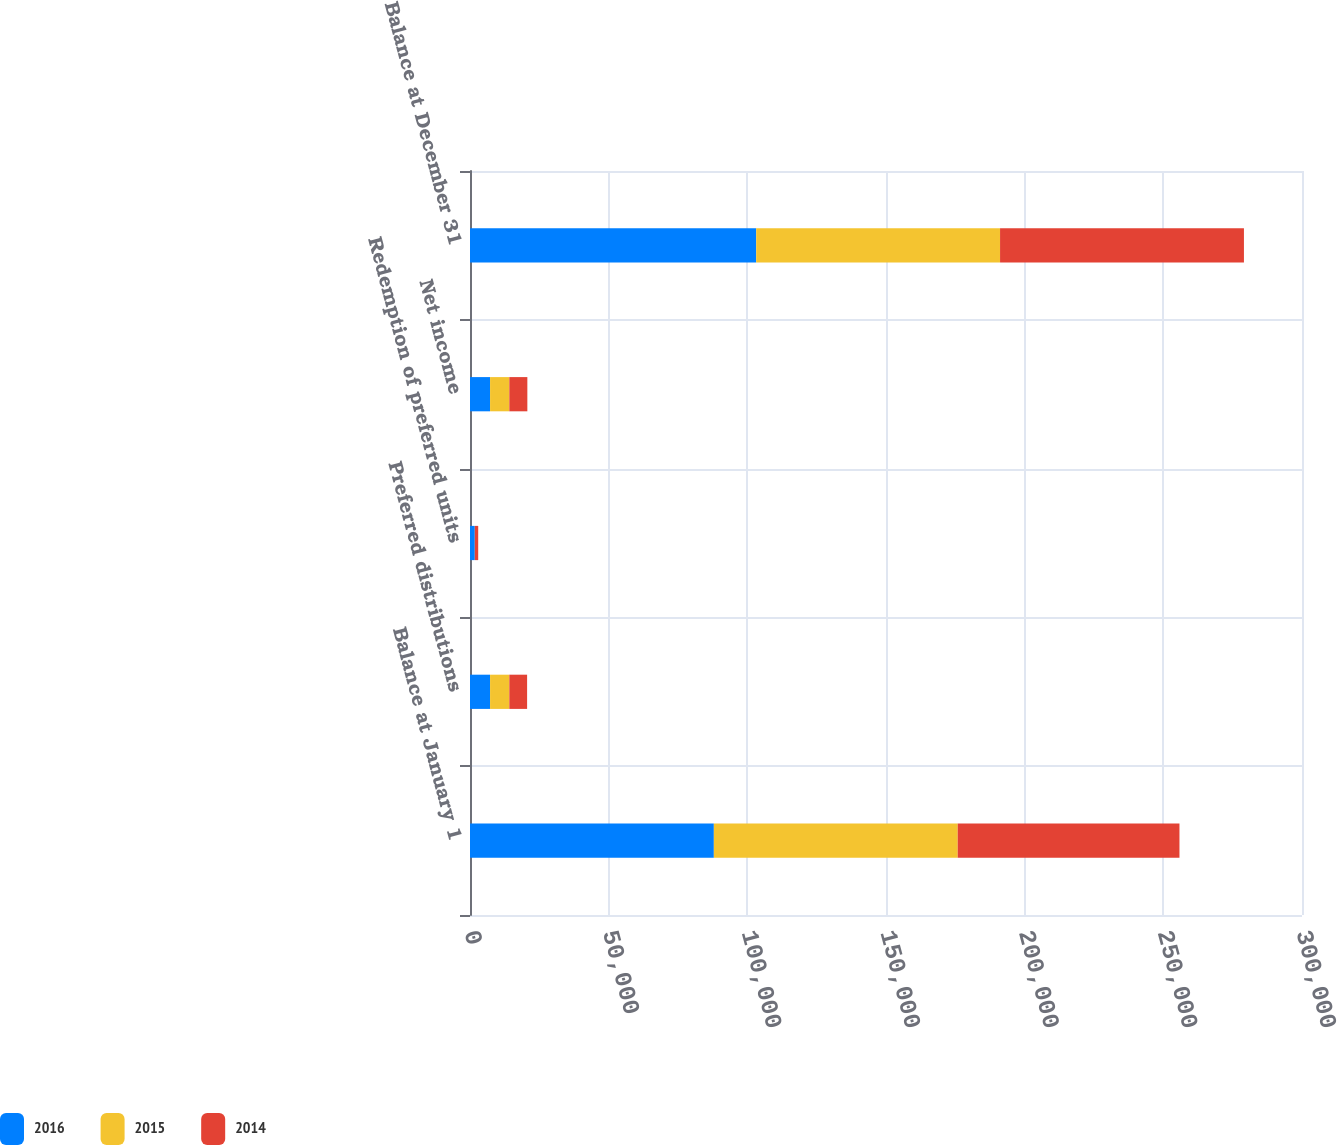Convert chart. <chart><loc_0><loc_0><loc_500><loc_500><stacked_bar_chart><ecel><fcel>Balance at January 1<fcel>Preferred distributions<fcel>Redemption of preferred units<fcel>Net income<fcel>Balance at December 31<nl><fcel>2016<fcel>87926<fcel>7239<fcel>1725<fcel>7239<fcel>103201<nl><fcel>2015<fcel>87937<fcel>6943<fcel>11<fcel>6943<fcel>87926<nl><fcel>2014<fcel>79953<fcel>6409<fcel>1221<fcel>6497<fcel>87937<nl></chart> 